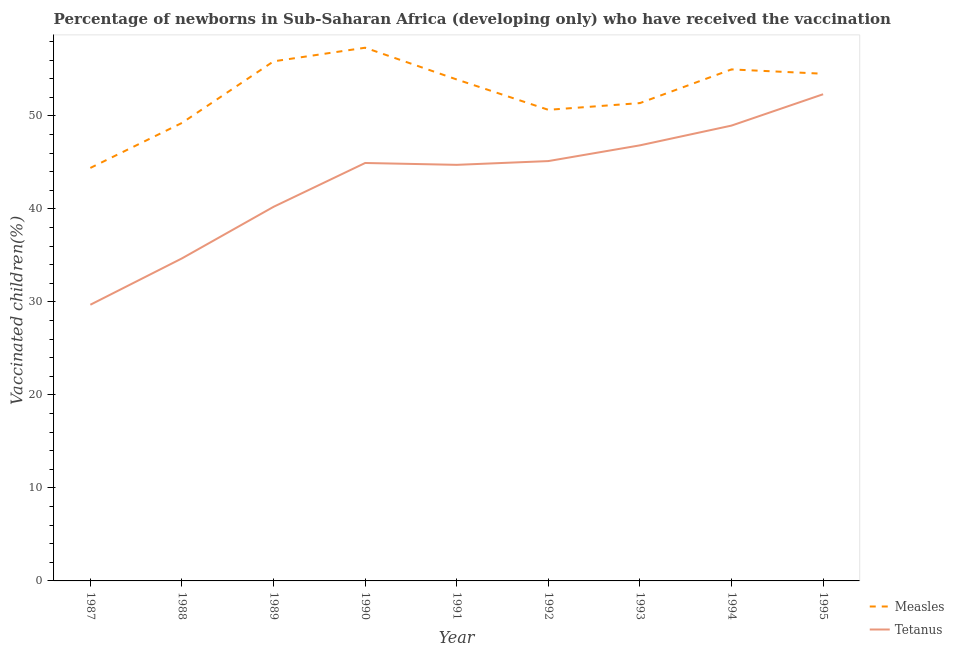How many different coloured lines are there?
Ensure brevity in your answer.  2. What is the percentage of newborns who received vaccination for tetanus in 1989?
Provide a short and direct response. 40.23. Across all years, what is the maximum percentage of newborns who received vaccination for tetanus?
Provide a succinct answer. 52.34. Across all years, what is the minimum percentage of newborns who received vaccination for tetanus?
Give a very brief answer. 29.7. What is the total percentage of newborns who received vaccination for measles in the graph?
Make the answer very short. 472.38. What is the difference between the percentage of newborns who received vaccination for measles in 1990 and that in 1994?
Offer a very short reply. 2.33. What is the difference between the percentage of newborns who received vaccination for measles in 1989 and the percentage of newborns who received vaccination for tetanus in 1994?
Your answer should be very brief. 6.91. What is the average percentage of newborns who received vaccination for measles per year?
Give a very brief answer. 52.49. In the year 1993, what is the difference between the percentage of newborns who received vaccination for tetanus and percentage of newborns who received vaccination for measles?
Give a very brief answer. -4.54. In how many years, is the percentage of newborns who received vaccination for tetanus greater than 16 %?
Offer a terse response. 9. What is the ratio of the percentage of newborns who received vaccination for tetanus in 1990 to that in 1995?
Ensure brevity in your answer.  0.86. Is the percentage of newborns who received vaccination for measles in 1988 less than that in 1993?
Keep it short and to the point. Yes. Is the difference between the percentage of newborns who received vaccination for tetanus in 1989 and 1995 greater than the difference between the percentage of newborns who received vaccination for measles in 1989 and 1995?
Keep it short and to the point. No. What is the difference between the highest and the second highest percentage of newborns who received vaccination for measles?
Give a very brief answer. 1.46. What is the difference between the highest and the lowest percentage of newborns who received vaccination for measles?
Your response must be concise. 12.93. In how many years, is the percentage of newborns who received vaccination for measles greater than the average percentage of newborns who received vaccination for measles taken over all years?
Provide a short and direct response. 5. Is the sum of the percentage of newborns who received vaccination for measles in 1992 and 1995 greater than the maximum percentage of newborns who received vaccination for tetanus across all years?
Your response must be concise. Yes. Is the percentage of newborns who received vaccination for tetanus strictly greater than the percentage of newborns who received vaccination for measles over the years?
Provide a succinct answer. No. Is the percentage of newborns who received vaccination for measles strictly less than the percentage of newborns who received vaccination for tetanus over the years?
Give a very brief answer. No. How many lines are there?
Provide a short and direct response. 2. Does the graph contain any zero values?
Your response must be concise. No. Does the graph contain grids?
Offer a very short reply. No. Where does the legend appear in the graph?
Provide a short and direct response. Bottom right. How many legend labels are there?
Give a very brief answer. 2. How are the legend labels stacked?
Ensure brevity in your answer.  Vertical. What is the title of the graph?
Your answer should be very brief. Percentage of newborns in Sub-Saharan Africa (developing only) who have received the vaccination. Does "Age 65(female)" appear as one of the legend labels in the graph?
Make the answer very short. No. What is the label or title of the Y-axis?
Your response must be concise. Vaccinated children(%)
. What is the Vaccinated children(%)
 of Measles in 1987?
Give a very brief answer. 44.41. What is the Vaccinated children(%)
 of Tetanus in 1987?
Offer a terse response. 29.7. What is the Vaccinated children(%)
 in Measles in 1988?
Offer a very short reply. 49.25. What is the Vaccinated children(%)
 in Tetanus in 1988?
Provide a short and direct response. 34.68. What is the Vaccinated children(%)
 of Measles in 1989?
Provide a succinct answer. 55.87. What is the Vaccinated children(%)
 in Tetanus in 1989?
Keep it short and to the point. 40.23. What is the Vaccinated children(%)
 in Measles in 1990?
Offer a very short reply. 57.34. What is the Vaccinated children(%)
 of Tetanus in 1990?
Provide a succinct answer. 44.94. What is the Vaccinated children(%)
 of Measles in 1991?
Your answer should be very brief. 53.92. What is the Vaccinated children(%)
 in Tetanus in 1991?
Offer a terse response. 44.74. What is the Vaccinated children(%)
 in Measles in 1992?
Make the answer very short. 50.66. What is the Vaccinated children(%)
 in Tetanus in 1992?
Your answer should be compact. 45.15. What is the Vaccinated children(%)
 of Measles in 1993?
Your response must be concise. 51.38. What is the Vaccinated children(%)
 in Tetanus in 1993?
Ensure brevity in your answer.  46.84. What is the Vaccinated children(%)
 of Measles in 1994?
Provide a short and direct response. 55.01. What is the Vaccinated children(%)
 in Tetanus in 1994?
Provide a short and direct response. 48.96. What is the Vaccinated children(%)
 of Measles in 1995?
Keep it short and to the point. 54.54. What is the Vaccinated children(%)
 of Tetanus in 1995?
Make the answer very short. 52.34. Across all years, what is the maximum Vaccinated children(%)
 of Measles?
Keep it short and to the point. 57.34. Across all years, what is the maximum Vaccinated children(%)
 of Tetanus?
Offer a very short reply. 52.34. Across all years, what is the minimum Vaccinated children(%)
 in Measles?
Ensure brevity in your answer.  44.41. Across all years, what is the minimum Vaccinated children(%)
 of Tetanus?
Your response must be concise. 29.7. What is the total Vaccinated children(%)
 of Measles in the graph?
Provide a short and direct response. 472.38. What is the total Vaccinated children(%)
 in Tetanus in the graph?
Offer a very short reply. 387.58. What is the difference between the Vaccinated children(%)
 in Measles in 1987 and that in 1988?
Offer a very short reply. -4.84. What is the difference between the Vaccinated children(%)
 in Tetanus in 1987 and that in 1988?
Ensure brevity in your answer.  -4.98. What is the difference between the Vaccinated children(%)
 in Measles in 1987 and that in 1989?
Your answer should be compact. -11.46. What is the difference between the Vaccinated children(%)
 in Tetanus in 1987 and that in 1989?
Ensure brevity in your answer.  -10.53. What is the difference between the Vaccinated children(%)
 in Measles in 1987 and that in 1990?
Your answer should be compact. -12.93. What is the difference between the Vaccinated children(%)
 in Tetanus in 1987 and that in 1990?
Your answer should be compact. -15.24. What is the difference between the Vaccinated children(%)
 of Measles in 1987 and that in 1991?
Give a very brief answer. -9.51. What is the difference between the Vaccinated children(%)
 in Tetanus in 1987 and that in 1991?
Provide a succinct answer. -15.04. What is the difference between the Vaccinated children(%)
 in Measles in 1987 and that in 1992?
Offer a very short reply. -6.25. What is the difference between the Vaccinated children(%)
 of Tetanus in 1987 and that in 1992?
Ensure brevity in your answer.  -15.45. What is the difference between the Vaccinated children(%)
 of Measles in 1987 and that in 1993?
Give a very brief answer. -6.97. What is the difference between the Vaccinated children(%)
 in Tetanus in 1987 and that in 1993?
Offer a very short reply. -17.14. What is the difference between the Vaccinated children(%)
 in Measles in 1987 and that in 1994?
Make the answer very short. -10.6. What is the difference between the Vaccinated children(%)
 of Tetanus in 1987 and that in 1994?
Your response must be concise. -19.27. What is the difference between the Vaccinated children(%)
 of Measles in 1987 and that in 1995?
Give a very brief answer. -10.13. What is the difference between the Vaccinated children(%)
 in Tetanus in 1987 and that in 1995?
Offer a terse response. -22.64. What is the difference between the Vaccinated children(%)
 in Measles in 1988 and that in 1989?
Provide a short and direct response. -6.62. What is the difference between the Vaccinated children(%)
 of Tetanus in 1988 and that in 1989?
Offer a terse response. -5.55. What is the difference between the Vaccinated children(%)
 in Measles in 1988 and that in 1990?
Provide a short and direct response. -8.09. What is the difference between the Vaccinated children(%)
 of Tetanus in 1988 and that in 1990?
Your answer should be very brief. -10.26. What is the difference between the Vaccinated children(%)
 in Measles in 1988 and that in 1991?
Provide a short and direct response. -4.67. What is the difference between the Vaccinated children(%)
 of Tetanus in 1988 and that in 1991?
Offer a terse response. -10.06. What is the difference between the Vaccinated children(%)
 in Measles in 1988 and that in 1992?
Your answer should be very brief. -1.41. What is the difference between the Vaccinated children(%)
 in Tetanus in 1988 and that in 1992?
Ensure brevity in your answer.  -10.46. What is the difference between the Vaccinated children(%)
 in Measles in 1988 and that in 1993?
Your answer should be very brief. -2.13. What is the difference between the Vaccinated children(%)
 of Tetanus in 1988 and that in 1993?
Provide a short and direct response. -12.16. What is the difference between the Vaccinated children(%)
 in Measles in 1988 and that in 1994?
Make the answer very short. -5.76. What is the difference between the Vaccinated children(%)
 in Tetanus in 1988 and that in 1994?
Your answer should be very brief. -14.28. What is the difference between the Vaccinated children(%)
 in Measles in 1988 and that in 1995?
Your answer should be very brief. -5.29. What is the difference between the Vaccinated children(%)
 in Tetanus in 1988 and that in 1995?
Provide a short and direct response. -17.65. What is the difference between the Vaccinated children(%)
 of Measles in 1989 and that in 1990?
Offer a terse response. -1.46. What is the difference between the Vaccinated children(%)
 in Tetanus in 1989 and that in 1990?
Offer a terse response. -4.71. What is the difference between the Vaccinated children(%)
 in Measles in 1989 and that in 1991?
Ensure brevity in your answer.  1.95. What is the difference between the Vaccinated children(%)
 in Tetanus in 1989 and that in 1991?
Provide a succinct answer. -4.51. What is the difference between the Vaccinated children(%)
 of Measles in 1989 and that in 1992?
Your answer should be very brief. 5.21. What is the difference between the Vaccinated children(%)
 of Tetanus in 1989 and that in 1992?
Provide a succinct answer. -4.92. What is the difference between the Vaccinated children(%)
 of Measles in 1989 and that in 1993?
Provide a succinct answer. 4.49. What is the difference between the Vaccinated children(%)
 in Tetanus in 1989 and that in 1993?
Your answer should be very brief. -6.61. What is the difference between the Vaccinated children(%)
 of Measles in 1989 and that in 1994?
Offer a very short reply. 0.87. What is the difference between the Vaccinated children(%)
 in Tetanus in 1989 and that in 1994?
Ensure brevity in your answer.  -8.74. What is the difference between the Vaccinated children(%)
 of Measles in 1989 and that in 1995?
Your response must be concise. 1.33. What is the difference between the Vaccinated children(%)
 in Tetanus in 1989 and that in 1995?
Your response must be concise. -12.11. What is the difference between the Vaccinated children(%)
 of Measles in 1990 and that in 1991?
Provide a succinct answer. 3.41. What is the difference between the Vaccinated children(%)
 of Tetanus in 1990 and that in 1991?
Provide a short and direct response. 0.2. What is the difference between the Vaccinated children(%)
 in Measles in 1990 and that in 1992?
Your answer should be very brief. 6.68. What is the difference between the Vaccinated children(%)
 of Tetanus in 1990 and that in 1992?
Ensure brevity in your answer.  -0.21. What is the difference between the Vaccinated children(%)
 of Measles in 1990 and that in 1993?
Give a very brief answer. 5.95. What is the difference between the Vaccinated children(%)
 in Tetanus in 1990 and that in 1993?
Keep it short and to the point. -1.9. What is the difference between the Vaccinated children(%)
 of Measles in 1990 and that in 1994?
Your answer should be compact. 2.33. What is the difference between the Vaccinated children(%)
 in Tetanus in 1990 and that in 1994?
Provide a succinct answer. -4.02. What is the difference between the Vaccinated children(%)
 in Measles in 1990 and that in 1995?
Ensure brevity in your answer.  2.8. What is the difference between the Vaccinated children(%)
 of Tetanus in 1990 and that in 1995?
Keep it short and to the point. -7.39. What is the difference between the Vaccinated children(%)
 in Measles in 1991 and that in 1992?
Offer a terse response. 3.26. What is the difference between the Vaccinated children(%)
 in Tetanus in 1991 and that in 1992?
Keep it short and to the point. -0.4. What is the difference between the Vaccinated children(%)
 in Measles in 1991 and that in 1993?
Provide a short and direct response. 2.54. What is the difference between the Vaccinated children(%)
 in Tetanus in 1991 and that in 1993?
Your answer should be compact. -2.1. What is the difference between the Vaccinated children(%)
 of Measles in 1991 and that in 1994?
Make the answer very short. -1.08. What is the difference between the Vaccinated children(%)
 in Tetanus in 1991 and that in 1994?
Provide a short and direct response. -4.22. What is the difference between the Vaccinated children(%)
 of Measles in 1991 and that in 1995?
Your answer should be very brief. -0.62. What is the difference between the Vaccinated children(%)
 in Tetanus in 1991 and that in 1995?
Your response must be concise. -7.59. What is the difference between the Vaccinated children(%)
 in Measles in 1992 and that in 1993?
Keep it short and to the point. -0.72. What is the difference between the Vaccinated children(%)
 in Tetanus in 1992 and that in 1993?
Offer a terse response. -1.69. What is the difference between the Vaccinated children(%)
 of Measles in 1992 and that in 1994?
Ensure brevity in your answer.  -4.34. What is the difference between the Vaccinated children(%)
 in Tetanus in 1992 and that in 1994?
Make the answer very short. -3.82. What is the difference between the Vaccinated children(%)
 of Measles in 1992 and that in 1995?
Ensure brevity in your answer.  -3.88. What is the difference between the Vaccinated children(%)
 of Tetanus in 1992 and that in 1995?
Keep it short and to the point. -7.19. What is the difference between the Vaccinated children(%)
 of Measles in 1993 and that in 1994?
Give a very brief answer. -3.62. What is the difference between the Vaccinated children(%)
 of Tetanus in 1993 and that in 1994?
Give a very brief answer. -2.12. What is the difference between the Vaccinated children(%)
 of Measles in 1993 and that in 1995?
Ensure brevity in your answer.  -3.16. What is the difference between the Vaccinated children(%)
 of Tetanus in 1993 and that in 1995?
Offer a very short reply. -5.5. What is the difference between the Vaccinated children(%)
 of Measles in 1994 and that in 1995?
Provide a short and direct response. 0.47. What is the difference between the Vaccinated children(%)
 in Tetanus in 1994 and that in 1995?
Provide a succinct answer. -3.37. What is the difference between the Vaccinated children(%)
 of Measles in 1987 and the Vaccinated children(%)
 of Tetanus in 1988?
Give a very brief answer. 9.73. What is the difference between the Vaccinated children(%)
 in Measles in 1987 and the Vaccinated children(%)
 in Tetanus in 1989?
Your answer should be compact. 4.18. What is the difference between the Vaccinated children(%)
 of Measles in 1987 and the Vaccinated children(%)
 of Tetanus in 1990?
Offer a terse response. -0.53. What is the difference between the Vaccinated children(%)
 of Measles in 1987 and the Vaccinated children(%)
 of Tetanus in 1991?
Provide a succinct answer. -0.33. What is the difference between the Vaccinated children(%)
 in Measles in 1987 and the Vaccinated children(%)
 in Tetanus in 1992?
Provide a succinct answer. -0.74. What is the difference between the Vaccinated children(%)
 of Measles in 1987 and the Vaccinated children(%)
 of Tetanus in 1993?
Offer a terse response. -2.43. What is the difference between the Vaccinated children(%)
 in Measles in 1987 and the Vaccinated children(%)
 in Tetanus in 1994?
Make the answer very short. -4.55. What is the difference between the Vaccinated children(%)
 in Measles in 1987 and the Vaccinated children(%)
 in Tetanus in 1995?
Your answer should be very brief. -7.93. What is the difference between the Vaccinated children(%)
 in Measles in 1988 and the Vaccinated children(%)
 in Tetanus in 1989?
Keep it short and to the point. 9.02. What is the difference between the Vaccinated children(%)
 in Measles in 1988 and the Vaccinated children(%)
 in Tetanus in 1990?
Offer a terse response. 4.31. What is the difference between the Vaccinated children(%)
 of Measles in 1988 and the Vaccinated children(%)
 of Tetanus in 1991?
Your response must be concise. 4.51. What is the difference between the Vaccinated children(%)
 of Measles in 1988 and the Vaccinated children(%)
 of Tetanus in 1992?
Your answer should be very brief. 4.1. What is the difference between the Vaccinated children(%)
 of Measles in 1988 and the Vaccinated children(%)
 of Tetanus in 1993?
Offer a very short reply. 2.41. What is the difference between the Vaccinated children(%)
 in Measles in 1988 and the Vaccinated children(%)
 in Tetanus in 1994?
Your answer should be compact. 0.29. What is the difference between the Vaccinated children(%)
 in Measles in 1988 and the Vaccinated children(%)
 in Tetanus in 1995?
Your answer should be very brief. -3.09. What is the difference between the Vaccinated children(%)
 in Measles in 1989 and the Vaccinated children(%)
 in Tetanus in 1990?
Make the answer very short. 10.93. What is the difference between the Vaccinated children(%)
 of Measles in 1989 and the Vaccinated children(%)
 of Tetanus in 1991?
Offer a terse response. 11.13. What is the difference between the Vaccinated children(%)
 of Measles in 1989 and the Vaccinated children(%)
 of Tetanus in 1992?
Make the answer very short. 10.73. What is the difference between the Vaccinated children(%)
 in Measles in 1989 and the Vaccinated children(%)
 in Tetanus in 1993?
Give a very brief answer. 9.03. What is the difference between the Vaccinated children(%)
 in Measles in 1989 and the Vaccinated children(%)
 in Tetanus in 1994?
Offer a terse response. 6.91. What is the difference between the Vaccinated children(%)
 of Measles in 1989 and the Vaccinated children(%)
 of Tetanus in 1995?
Keep it short and to the point. 3.54. What is the difference between the Vaccinated children(%)
 in Measles in 1990 and the Vaccinated children(%)
 in Tetanus in 1991?
Offer a very short reply. 12.59. What is the difference between the Vaccinated children(%)
 of Measles in 1990 and the Vaccinated children(%)
 of Tetanus in 1992?
Keep it short and to the point. 12.19. What is the difference between the Vaccinated children(%)
 of Measles in 1990 and the Vaccinated children(%)
 of Tetanus in 1993?
Offer a very short reply. 10.5. What is the difference between the Vaccinated children(%)
 of Measles in 1990 and the Vaccinated children(%)
 of Tetanus in 1994?
Your answer should be very brief. 8.37. What is the difference between the Vaccinated children(%)
 in Measles in 1990 and the Vaccinated children(%)
 in Tetanus in 1995?
Provide a succinct answer. 5. What is the difference between the Vaccinated children(%)
 in Measles in 1991 and the Vaccinated children(%)
 in Tetanus in 1992?
Your response must be concise. 8.77. What is the difference between the Vaccinated children(%)
 in Measles in 1991 and the Vaccinated children(%)
 in Tetanus in 1993?
Your answer should be very brief. 7.08. What is the difference between the Vaccinated children(%)
 of Measles in 1991 and the Vaccinated children(%)
 of Tetanus in 1994?
Your answer should be very brief. 4.96. What is the difference between the Vaccinated children(%)
 of Measles in 1991 and the Vaccinated children(%)
 of Tetanus in 1995?
Provide a short and direct response. 1.59. What is the difference between the Vaccinated children(%)
 of Measles in 1992 and the Vaccinated children(%)
 of Tetanus in 1993?
Your response must be concise. 3.82. What is the difference between the Vaccinated children(%)
 in Measles in 1992 and the Vaccinated children(%)
 in Tetanus in 1994?
Your answer should be very brief. 1.7. What is the difference between the Vaccinated children(%)
 in Measles in 1992 and the Vaccinated children(%)
 in Tetanus in 1995?
Offer a very short reply. -1.68. What is the difference between the Vaccinated children(%)
 of Measles in 1993 and the Vaccinated children(%)
 of Tetanus in 1994?
Keep it short and to the point. 2.42. What is the difference between the Vaccinated children(%)
 of Measles in 1993 and the Vaccinated children(%)
 of Tetanus in 1995?
Make the answer very short. -0.95. What is the difference between the Vaccinated children(%)
 in Measles in 1994 and the Vaccinated children(%)
 in Tetanus in 1995?
Your answer should be very brief. 2.67. What is the average Vaccinated children(%)
 of Measles per year?
Your answer should be compact. 52.49. What is the average Vaccinated children(%)
 of Tetanus per year?
Your answer should be very brief. 43.06. In the year 1987, what is the difference between the Vaccinated children(%)
 of Measles and Vaccinated children(%)
 of Tetanus?
Your response must be concise. 14.71. In the year 1988, what is the difference between the Vaccinated children(%)
 of Measles and Vaccinated children(%)
 of Tetanus?
Your answer should be very brief. 14.57. In the year 1989, what is the difference between the Vaccinated children(%)
 in Measles and Vaccinated children(%)
 in Tetanus?
Provide a short and direct response. 15.64. In the year 1990, what is the difference between the Vaccinated children(%)
 in Measles and Vaccinated children(%)
 in Tetanus?
Ensure brevity in your answer.  12.39. In the year 1991, what is the difference between the Vaccinated children(%)
 in Measles and Vaccinated children(%)
 in Tetanus?
Your response must be concise. 9.18. In the year 1992, what is the difference between the Vaccinated children(%)
 of Measles and Vaccinated children(%)
 of Tetanus?
Offer a terse response. 5.51. In the year 1993, what is the difference between the Vaccinated children(%)
 in Measles and Vaccinated children(%)
 in Tetanus?
Make the answer very short. 4.54. In the year 1994, what is the difference between the Vaccinated children(%)
 of Measles and Vaccinated children(%)
 of Tetanus?
Keep it short and to the point. 6.04. In the year 1995, what is the difference between the Vaccinated children(%)
 of Measles and Vaccinated children(%)
 of Tetanus?
Your answer should be compact. 2.2. What is the ratio of the Vaccinated children(%)
 of Measles in 1987 to that in 1988?
Give a very brief answer. 0.9. What is the ratio of the Vaccinated children(%)
 of Tetanus in 1987 to that in 1988?
Offer a terse response. 0.86. What is the ratio of the Vaccinated children(%)
 in Measles in 1987 to that in 1989?
Ensure brevity in your answer.  0.79. What is the ratio of the Vaccinated children(%)
 in Tetanus in 1987 to that in 1989?
Provide a short and direct response. 0.74. What is the ratio of the Vaccinated children(%)
 of Measles in 1987 to that in 1990?
Make the answer very short. 0.77. What is the ratio of the Vaccinated children(%)
 in Tetanus in 1987 to that in 1990?
Keep it short and to the point. 0.66. What is the ratio of the Vaccinated children(%)
 of Measles in 1987 to that in 1991?
Make the answer very short. 0.82. What is the ratio of the Vaccinated children(%)
 in Tetanus in 1987 to that in 1991?
Ensure brevity in your answer.  0.66. What is the ratio of the Vaccinated children(%)
 in Measles in 1987 to that in 1992?
Provide a short and direct response. 0.88. What is the ratio of the Vaccinated children(%)
 of Tetanus in 1987 to that in 1992?
Offer a terse response. 0.66. What is the ratio of the Vaccinated children(%)
 of Measles in 1987 to that in 1993?
Make the answer very short. 0.86. What is the ratio of the Vaccinated children(%)
 of Tetanus in 1987 to that in 1993?
Provide a short and direct response. 0.63. What is the ratio of the Vaccinated children(%)
 in Measles in 1987 to that in 1994?
Provide a short and direct response. 0.81. What is the ratio of the Vaccinated children(%)
 of Tetanus in 1987 to that in 1994?
Keep it short and to the point. 0.61. What is the ratio of the Vaccinated children(%)
 of Measles in 1987 to that in 1995?
Your answer should be compact. 0.81. What is the ratio of the Vaccinated children(%)
 in Tetanus in 1987 to that in 1995?
Ensure brevity in your answer.  0.57. What is the ratio of the Vaccinated children(%)
 in Measles in 1988 to that in 1989?
Your answer should be very brief. 0.88. What is the ratio of the Vaccinated children(%)
 of Tetanus in 1988 to that in 1989?
Give a very brief answer. 0.86. What is the ratio of the Vaccinated children(%)
 in Measles in 1988 to that in 1990?
Your answer should be very brief. 0.86. What is the ratio of the Vaccinated children(%)
 in Tetanus in 1988 to that in 1990?
Offer a terse response. 0.77. What is the ratio of the Vaccinated children(%)
 in Measles in 1988 to that in 1991?
Offer a very short reply. 0.91. What is the ratio of the Vaccinated children(%)
 of Tetanus in 1988 to that in 1991?
Your response must be concise. 0.78. What is the ratio of the Vaccinated children(%)
 of Measles in 1988 to that in 1992?
Offer a terse response. 0.97. What is the ratio of the Vaccinated children(%)
 in Tetanus in 1988 to that in 1992?
Provide a short and direct response. 0.77. What is the ratio of the Vaccinated children(%)
 of Measles in 1988 to that in 1993?
Keep it short and to the point. 0.96. What is the ratio of the Vaccinated children(%)
 of Tetanus in 1988 to that in 1993?
Provide a succinct answer. 0.74. What is the ratio of the Vaccinated children(%)
 in Measles in 1988 to that in 1994?
Give a very brief answer. 0.9. What is the ratio of the Vaccinated children(%)
 in Tetanus in 1988 to that in 1994?
Offer a very short reply. 0.71. What is the ratio of the Vaccinated children(%)
 of Measles in 1988 to that in 1995?
Offer a very short reply. 0.9. What is the ratio of the Vaccinated children(%)
 in Tetanus in 1988 to that in 1995?
Provide a succinct answer. 0.66. What is the ratio of the Vaccinated children(%)
 in Measles in 1989 to that in 1990?
Make the answer very short. 0.97. What is the ratio of the Vaccinated children(%)
 in Tetanus in 1989 to that in 1990?
Give a very brief answer. 0.9. What is the ratio of the Vaccinated children(%)
 in Measles in 1989 to that in 1991?
Offer a terse response. 1.04. What is the ratio of the Vaccinated children(%)
 of Tetanus in 1989 to that in 1991?
Your answer should be compact. 0.9. What is the ratio of the Vaccinated children(%)
 of Measles in 1989 to that in 1992?
Make the answer very short. 1.1. What is the ratio of the Vaccinated children(%)
 of Tetanus in 1989 to that in 1992?
Provide a short and direct response. 0.89. What is the ratio of the Vaccinated children(%)
 of Measles in 1989 to that in 1993?
Provide a short and direct response. 1.09. What is the ratio of the Vaccinated children(%)
 of Tetanus in 1989 to that in 1993?
Offer a terse response. 0.86. What is the ratio of the Vaccinated children(%)
 of Measles in 1989 to that in 1994?
Provide a short and direct response. 1.02. What is the ratio of the Vaccinated children(%)
 of Tetanus in 1989 to that in 1994?
Your answer should be compact. 0.82. What is the ratio of the Vaccinated children(%)
 of Measles in 1989 to that in 1995?
Offer a very short reply. 1.02. What is the ratio of the Vaccinated children(%)
 in Tetanus in 1989 to that in 1995?
Your response must be concise. 0.77. What is the ratio of the Vaccinated children(%)
 in Measles in 1990 to that in 1991?
Your answer should be compact. 1.06. What is the ratio of the Vaccinated children(%)
 of Tetanus in 1990 to that in 1991?
Keep it short and to the point. 1. What is the ratio of the Vaccinated children(%)
 of Measles in 1990 to that in 1992?
Give a very brief answer. 1.13. What is the ratio of the Vaccinated children(%)
 in Tetanus in 1990 to that in 1992?
Your answer should be compact. 1. What is the ratio of the Vaccinated children(%)
 in Measles in 1990 to that in 1993?
Your answer should be very brief. 1.12. What is the ratio of the Vaccinated children(%)
 in Tetanus in 1990 to that in 1993?
Give a very brief answer. 0.96. What is the ratio of the Vaccinated children(%)
 of Measles in 1990 to that in 1994?
Offer a very short reply. 1.04. What is the ratio of the Vaccinated children(%)
 of Tetanus in 1990 to that in 1994?
Make the answer very short. 0.92. What is the ratio of the Vaccinated children(%)
 of Measles in 1990 to that in 1995?
Give a very brief answer. 1.05. What is the ratio of the Vaccinated children(%)
 of Tetanus in 1990 to that in 1995?
Give a very brief answer. 0.86. What is the ratio of the Vaccinated children(%)
 in Measles in 1991 to that in 1992?
Your answer should be compact. 1.06. What is the ratio of the Vaccinated children(%)
 in Measles in 1991 to that in 1993?
Make the answer very short. 1.05. What is the ratio of the Vaccinated children(%)
 of Tetanus in 1991 to that in 1993?
Your response must be concise. 0.96. What is the ratio of the Vaccinated children(%)
 of Measles in 1991 to that in 1994?
Provide a short and direct response. 0.98. What is the ratio of the Vaccinated children(%)
 of Tetanus in 1991 to that in 1994?
Your answer should be very brief. 0.91. What is the ratio of the Vaccinated children(%)
 of Measles in 1991 to that in 1995?
Provide a short and direct response. 0.99. What is the ratio of the Vaccinated children(%)
 of Tetanus in 1991 to that in 1995?
Your response must be concise. 0.85. What is the ratio of the Vaccinated children(%)
 of Measles in 1992 to that in 1993?
Give a very brief answer. 0.99. What is the ratio of the Vaccinated children(%)
 in Tetanus in 1992 to that in 1993?
Provide a succinct answer. 0.96. What is the ratio of the Vaccinated children(%)
 of Measles in 1992 to that in 1994?
Your response must be concise. 0.92. What is the ratio of the Vaccinated children(%)
 of Tetanus in 1992 to that in 1994?
Your response must be concise. 0.92. What is the ratio of the Vaccinated children(%)
 of Measles in 1992 to that in 1995?
Your answer should be compact. 0.93. What is the ratio of the Vaccinated children(%)
 of Tetanus in 1992 to that in 1995?
Your answer should be compact. 0.86. What is the ratio of the Vaccinated children(%)
 of Measles in 1993 to that in 1994?
Ensure brevity in your answer.  0.93. What is the ratio of the Vaccinated children(%)
 in Tetanus in 1993 to that in 1994?
Provide a succinct answer. 0.96. What is the ratio of the Vaccinated children(%)
 in Measles in 1993 to that in 1995?
Offer a very short reply. 0.94. What is the ratio of the Vaccinated children(%)
 of Tetanus in 1993 to that in 1995?
Provide a succinct answer. 0.9. What is the ratio of the Vaccinated children(%)
 of Measles in 1994 to that in 1995?
Offer a very short reply. 1.01. What is the ratio of the Vaccinated children(%)
 in Tetanus in 1994 to that in 1995?
Ensure brevity in your answer.  0.94. What is the difference between the highest and the second highest Vaccinated children(%)
 in Measles?
Your answer should be compact. 1.46. What is the difference between the highest and the second highest Vaccinated children(%)
 in Tetanus?
Offer a terse response. 3.37. What is the difference between the highest and the lowest Vaccinated children(%)
 in Measles?
Offer a terse response. 12.93. What is the difference between the highest and the lowest Vaccinated children(%)
 in Tetanus?
Keep it short and to the point. 22.64. 